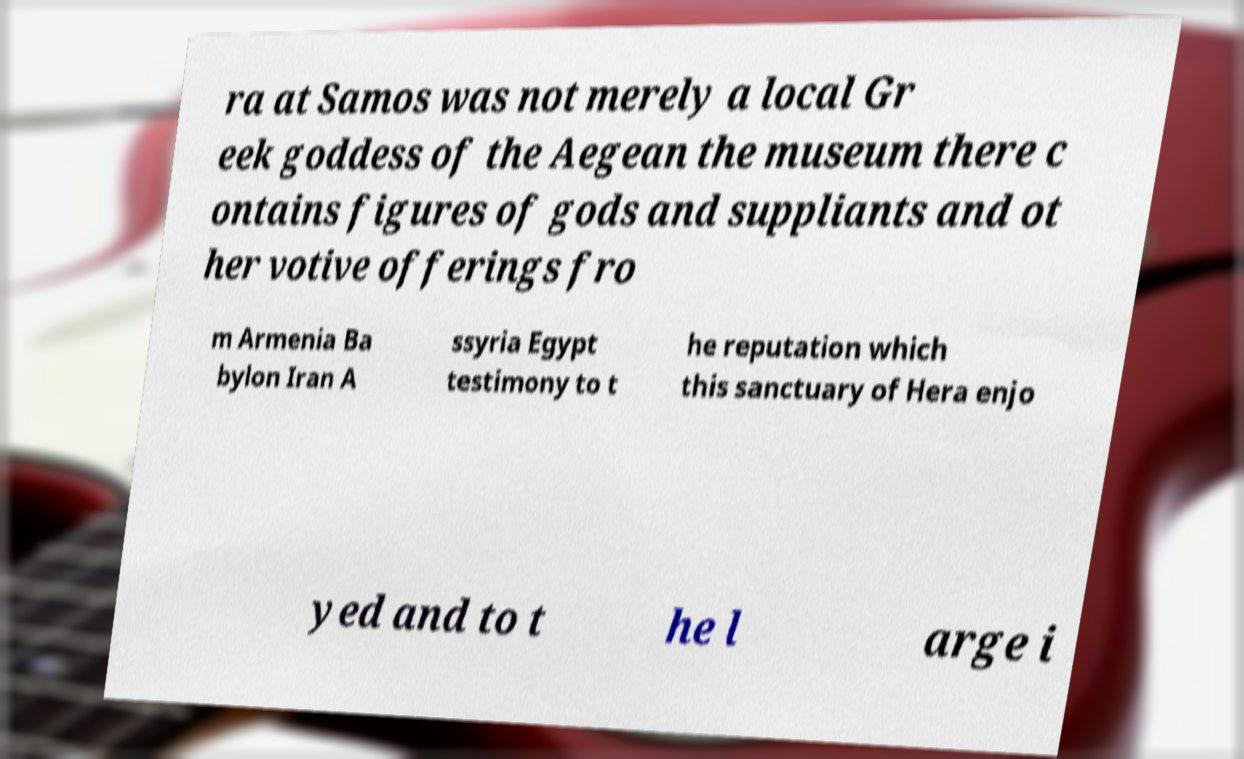Could you extract and type out the text from this image? ra at Samos was not merely a local Gr eek goddess of the Aegean the museum there c ontains figures of gods and suppliants and ot her votive offerings fro m Armenia Ba bylon Iran A ssyria Egypt testimony to t he reputation which this sanctuary of Hera enjo yed and to t he l arge i 